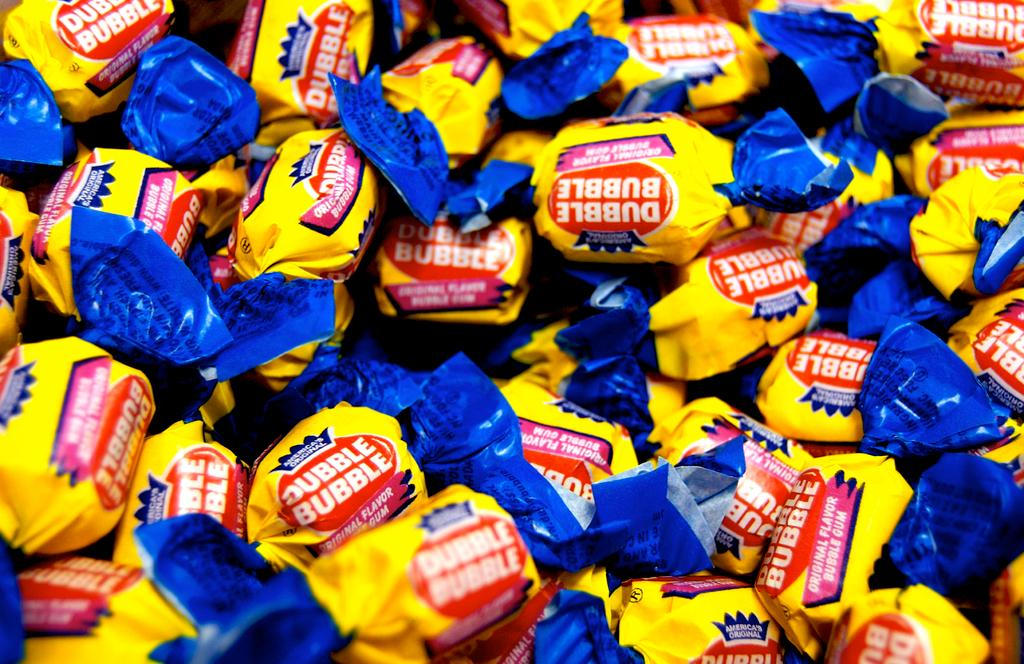What type of food can be seen in the image? There are candies in the image. How are the candies wrapped? The candies are wrapped with yellow and blue papers. Is there any text or design on the wrappers? Yes, there is writing on the wrappers. Can you see a rat eating the candies in the image? No, there is no rat present in the image. Is there a crow flying over the candies in the image? No, there is no crow present in the image. 